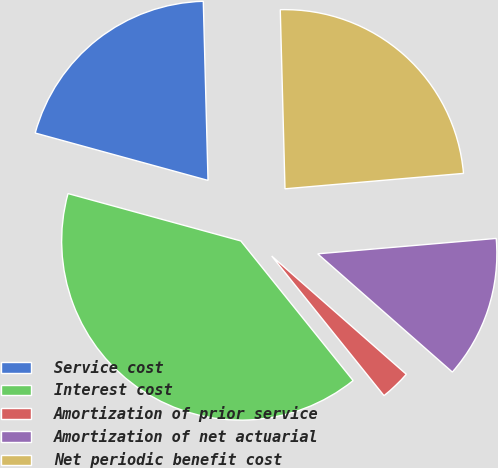<chart> <loc_0><loc_0><loc_500><loc_500><pie_chart><fcel>Service cost<fcel>Interest cost<fcel>Amortization of prior service<fcel>Amortization of net actuarial<fcel>Net periodic benefit cost<nl><fcel>20.32%<fcel>40.04%<fcel>2.75%<fcel>12.84%<fcel>24.05%<nl></chart> 